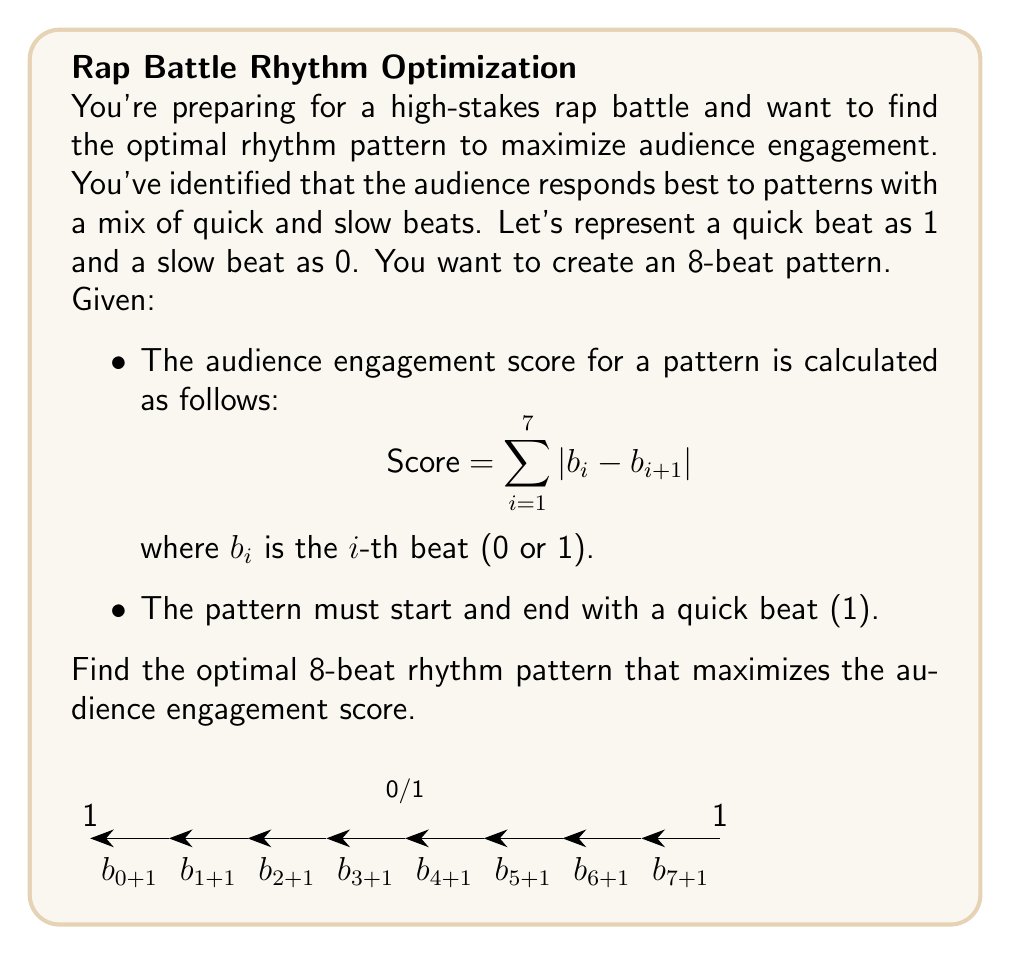What is the answer to this math problem? Let's approach this step-by-step:

1) We know the pattern must start and end with 1, so we have:
   1 _ _ _ _ _ _ 1

2) The score is maximized when there are frequent changes between 0 and 1. 

3) To maximize changes, we should alternate between 0 and 1 as much as possible.

4) Starting with 1, the optimal pattern would be:
   1 0 1 0 1 0 1 1

5) Let's calculate the score:
   $$ Score = |1-0| + |0-1| + |1-0| + |0-1| + |1-0| + |0-1| + |1-1| $$
   $$ Score = 1 + 1 + 1 + 1 + 1 + 1 + 0 = 6 $$

6) We can prove this is optimal:
   - The maximum possible score for 7 transitions is 7 (if every transition changed).
   - We're forced to have one transition that doesn't change (the last one), so 6 is the maximum achievable score.

7) Therefore, 10101011 is the optimal pattern.
Answer: 10101011 